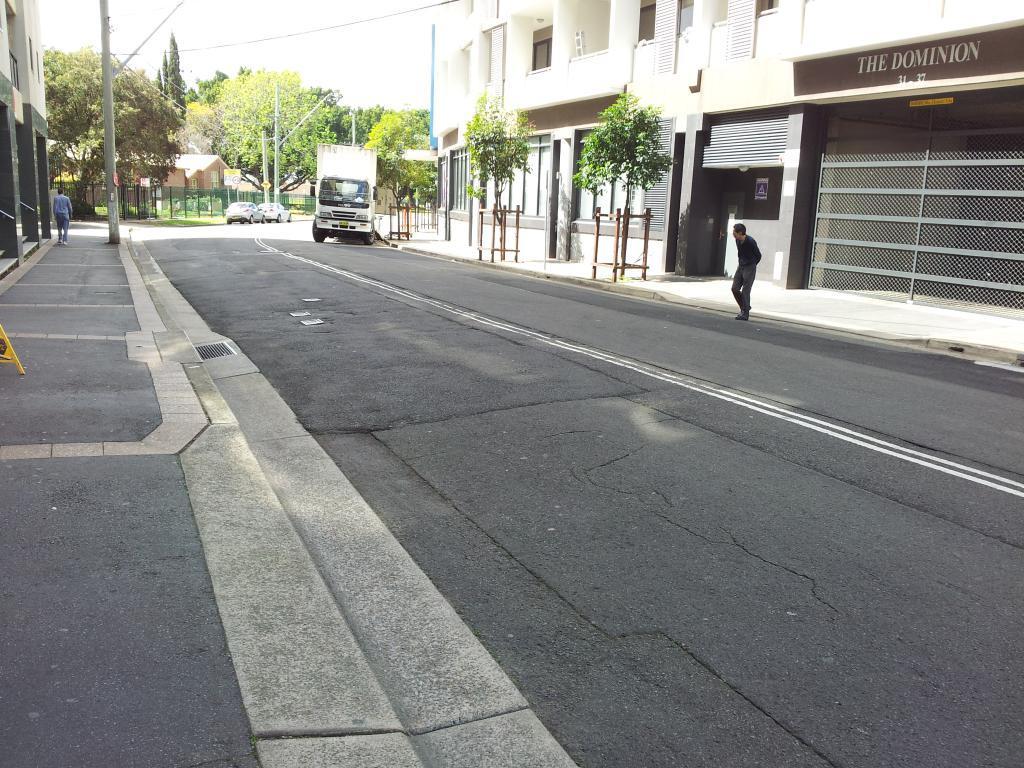In one or two sentences, can you explain what this image depicts? In this image we can see persons standing on the road, motor vehicles, street poles, street lights, electric cables, buildings, plants, name boards, mesh and sky. 